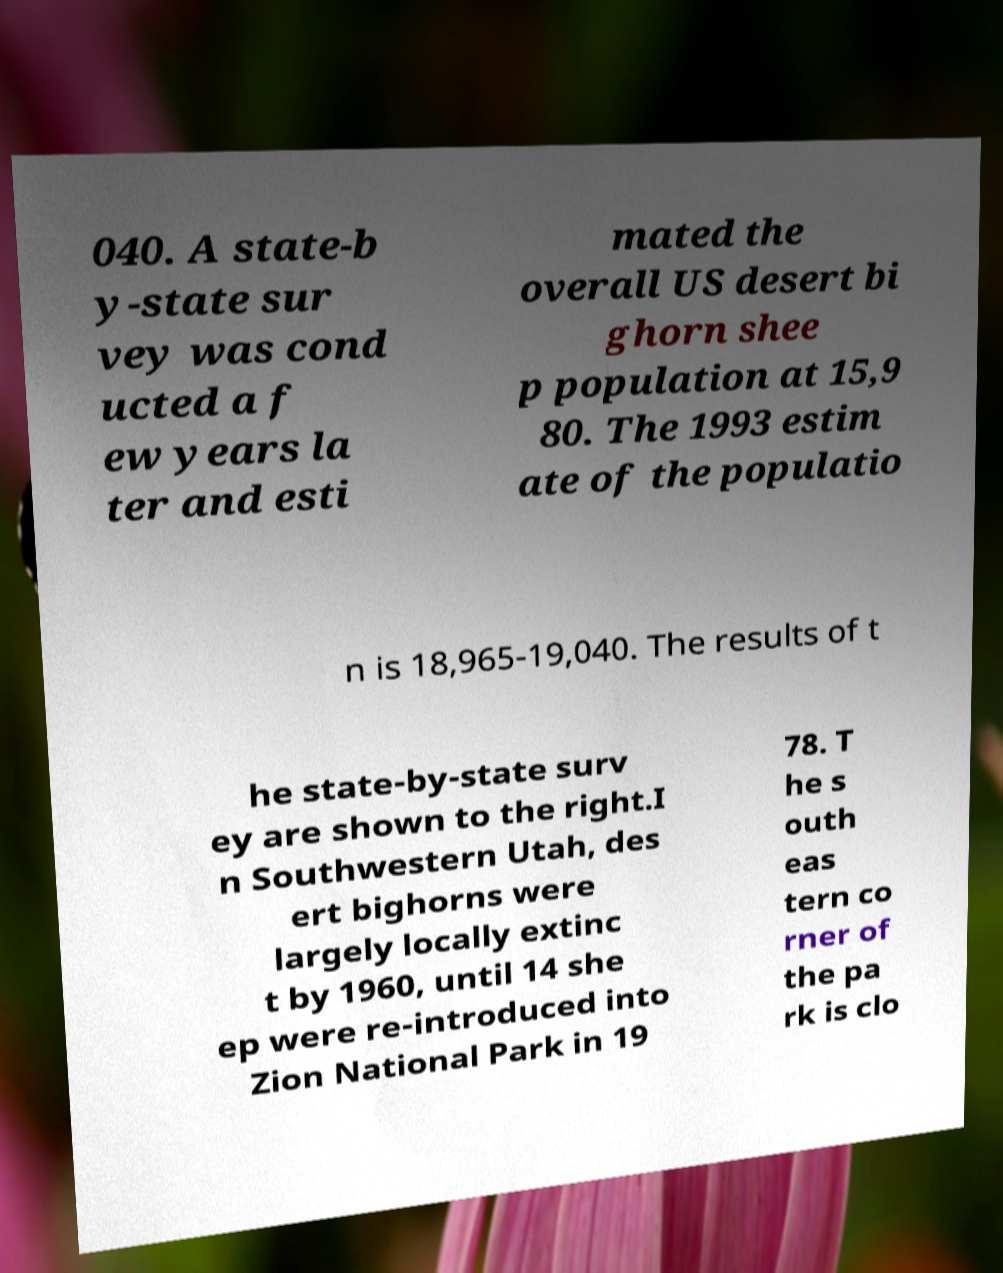Can you read and provide the text displayed in the image?This photo seems to have some interesting text. Can you extract and type it out for me? 040. A state-b y-state sur vey was cond ucted a f ew years la ter and esti mated the overall US desert bi ghorn shee p population at 15,9 80. The 1993 estim ate of the populatio n is 18,965-19,040. The results of t he state-by-state surv ey are shown to the right.I n Southwestern Utah, des ert bighorns were largely locally extinc t by 1960, until 14 she ep were re-introduced into Zion National Park in 19 78. T he s outh eas tern co rner of the pa rk is clo 